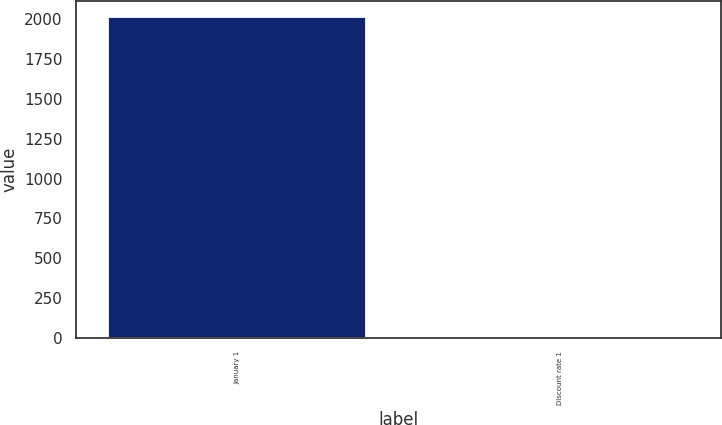<chart> <loc_0><loc_0><loc_500><loc_500><bar_chart><fcel>January 1<fcel>Discount rate 1<nl><fcel>2015<fcel>3.6<nl></chart> 